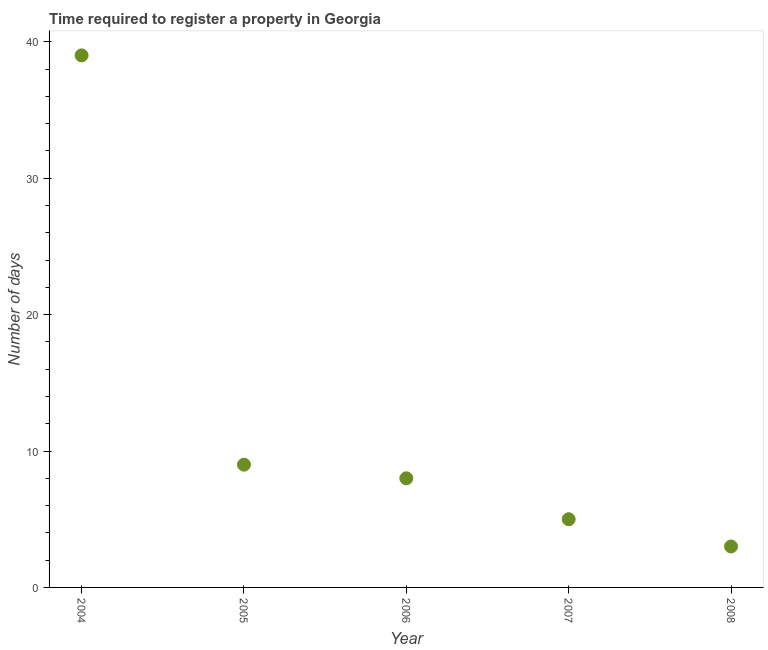What is the number of days required to register property in 2006?
Offer a terse response. 8. Across all years, what is the maximum number of days required to register property?
Ensure brevity in your answer.  39. Across all years, what is the minimum number of days required to register property?
Your response must be concise. 3. What is the sum of the number of days required to register property?
Your response must be concise. 64. What is the median number of days required to register property?
Ensure brevity in your answer.  8. In how many years, is the number of days required to register property greater than 6 days?
Ensure brevity in your answer.  3. Do a majority of the years between 2007 and 2004 (inclusive) have number of days required to register property greater than 16 days?
Provide a short and direct response. Yes. What is the ratio of the number of days required to register property in 2006 to that in 2007?
Give a very brief answer. 1.6. Is the difference between the number of days required to register property in 2004 and 2005 greater than the difference between any two years?
Provide a short and direct response. No. What is the difference between the highest and the lowest number of days required to register property?
Your answer should be very brief. 36. In how many years, is the number of days required to register property greater than the average number of days required to register property taken over all years?
Ensure brevity in your answer.  1. Does the number of days required to register property monotonically increase over the years?
Offer a terse response. No. Does the graph contain grids?
Your answer should be compact. No. What is the title of the graph?
Your answer should be compact. Time required to register a property in Georgia. What is the label or title of the X-axis?
Give a very brief answer. Year. What is the label or title of the Y-axis?
Offer a very short reply. Number of days. What is the Number of days in 2004?
Give a very brief answer. 39. What is the Number of days in 2005?
Offer a terse response. 9. What is the Number of days in 2006?
Offer a terse response. 8. What is the Number of days in 2007?
Your answer should be compact. 5. What is the Number of days in 2008?
Ensure brevity in your answer.  3. What is the difference between the Number of days in 2004 and 2005?
Your answer should be compact. 30. What is the difference between the Number of days in 2004 and 2006?
Your answer should be very brief. 31. What is the difference between the Number of days in 2005 and 2008?
Your answer should be compact. 6. What is the ratio of the Number of days in 2004 to that in 2005?
Your answer should be very brief. 4.33. What is the ratio of the Number of days in 2004 to that in 2006?
Ensure brevity in your answer.  4.88. What is the ratio of the Number of days in 2005 to that in 2006?
Provide a short and direct response. 1.12. What is the ratio of the Number of days in 2006 to that in 2007?
Offer a very short reply. 1.6. What is the ratio of the Number of days in 2006 to that in 2008?
Your answer should be compact. 2.67. What is the ratio of the Number of days in 2007 to that in 2008?
Make the answer very short. 1.67. 